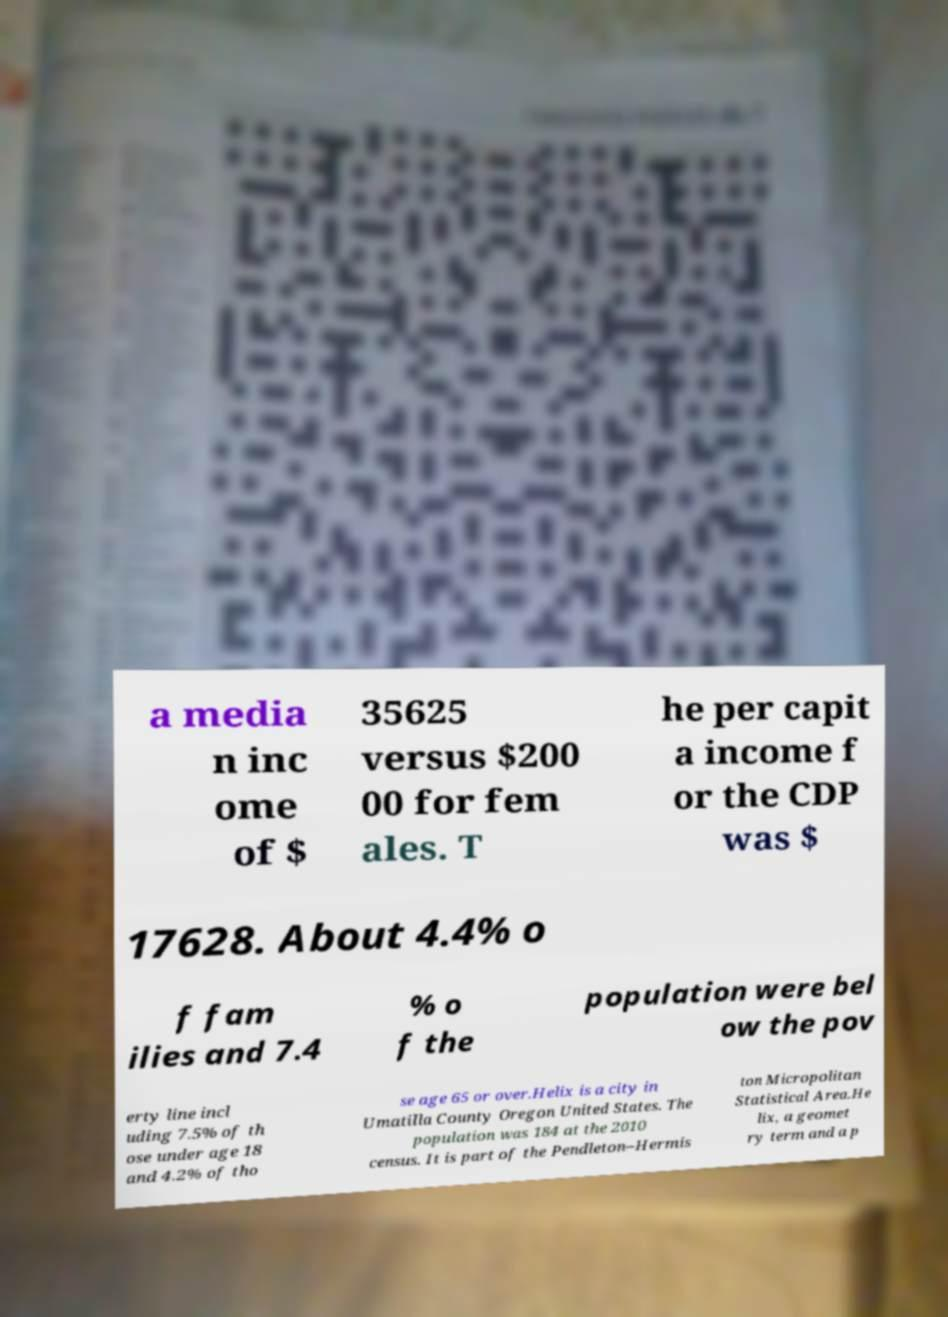Can you read and provide the text displayed in the image?This photo seems to have some interesting text. Can you extract and type it out for me? a media n inc ome of $ 35625 versus $200 00 for fem ales. T he per capit a income f or the CDP was $ 17628. About 4.4% o f fam ilies and 7.4 % o f the population were bel ow the pov erty line incl uding 7.5% of th ose under age 18 and 4.2% of tho se age 65 or over.Helix is a city in Umatilla County Oregon United States. The population was 184 at the 2010 census. It is part of the Pendleton–Hermis ton Micropolitan Statistical Area.He lix, a geomet ry term and a p 